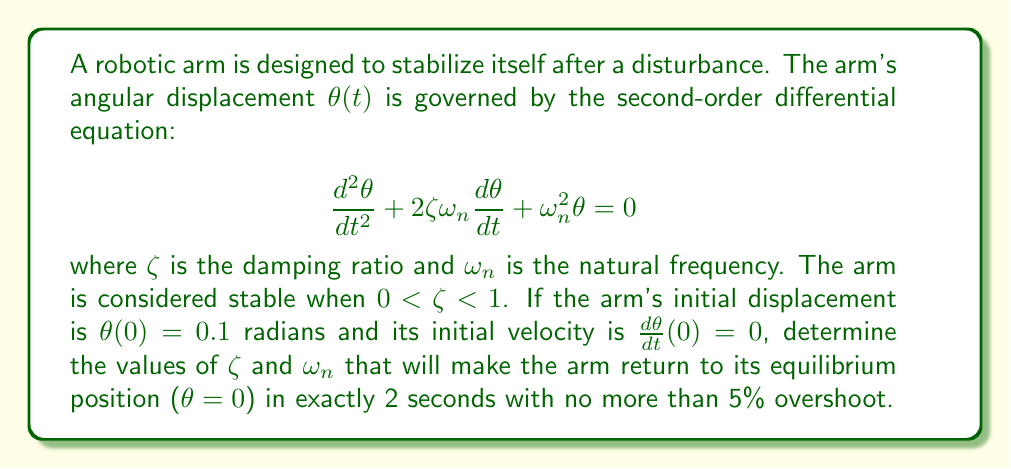Could you help me with this problem? To solve this problem, we need to consider the following steps:

1) For a second-order system with $0 < \zeta < 1$, the solution has the form:

   $$\theta(t) = Ae^{-\zeta\omega_n t}\sin(\omega_d t + \phi)$$

   where $\omega_d = \omega_n\sqrt{1-\zeta^2}$ is the damped natural frequency.

2) The percent overshoot (PO) is given by:

   $$PO = 100e^{-\zeta\pi/\sqrt{1-\zeta^2}}$$

   Setting this to 5%, we can solve for $\zeta$:

   $$0.05 = e^{-\zeta\pi/\sqrt{1-\zeta^2}}$$
   $$\zeta \approx 0.69$$

3) The settling time $t_s$ for the system to reach and stay within 2% of its final value is approximately:

   $$t_s \approx \frac{4}{\zeta\omega_n}$$

   Since we want the arm to reach equilibrium in exactly 2 seconds, we set $t_s = 2$:

   $$2 = \frac{4}{\zeta\omega_n}$$
   $$\omega_n = \frac{4}{\zeta \cdot 2} = \frac{2}{\zeta} \approx 2.90$$

4) To verify these values, we can use the initial conditions:

   $\theta(0) = 0.1 = A\sin(\phi)$
   $\frac{d\theta}{dt}(0) = 0 = A\omega_d\cos(\phi) - A\zeta\omega_n\sin(\phi)$

   From these, we can determine $A$ and $\phi$, but it's not necessary for finding $\zeta$ and $\omega_n$.

5) These values of $\zeta$ and $\omega_n$ ensure that the arm will return to equilibrium in 2 seconds with no more than 5% overshoot.
Answer: $\zeta \approx 0.69$ and $\omega_n \approx 2.90$ rad/s 